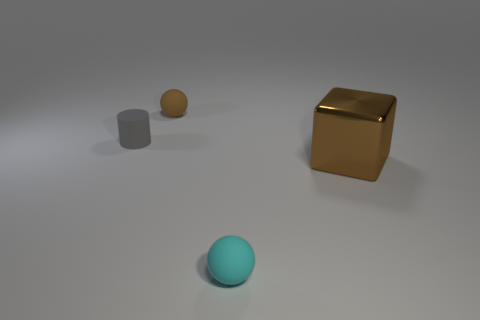Add 3 metal objects. How many objects exist? 7 Subtract all cubes. How many objects are left? 3 Add 4 tiny cyan objects. How many tiny cyan objects exist? 5 Subtract 0 green spheres. How many objects are left? 4 Subtract all cyan things. Subtract all tiny gray cylinders. How many objects are left? 2 Add 1 tiny brown balls. How many tiny brown balls are left? 2 